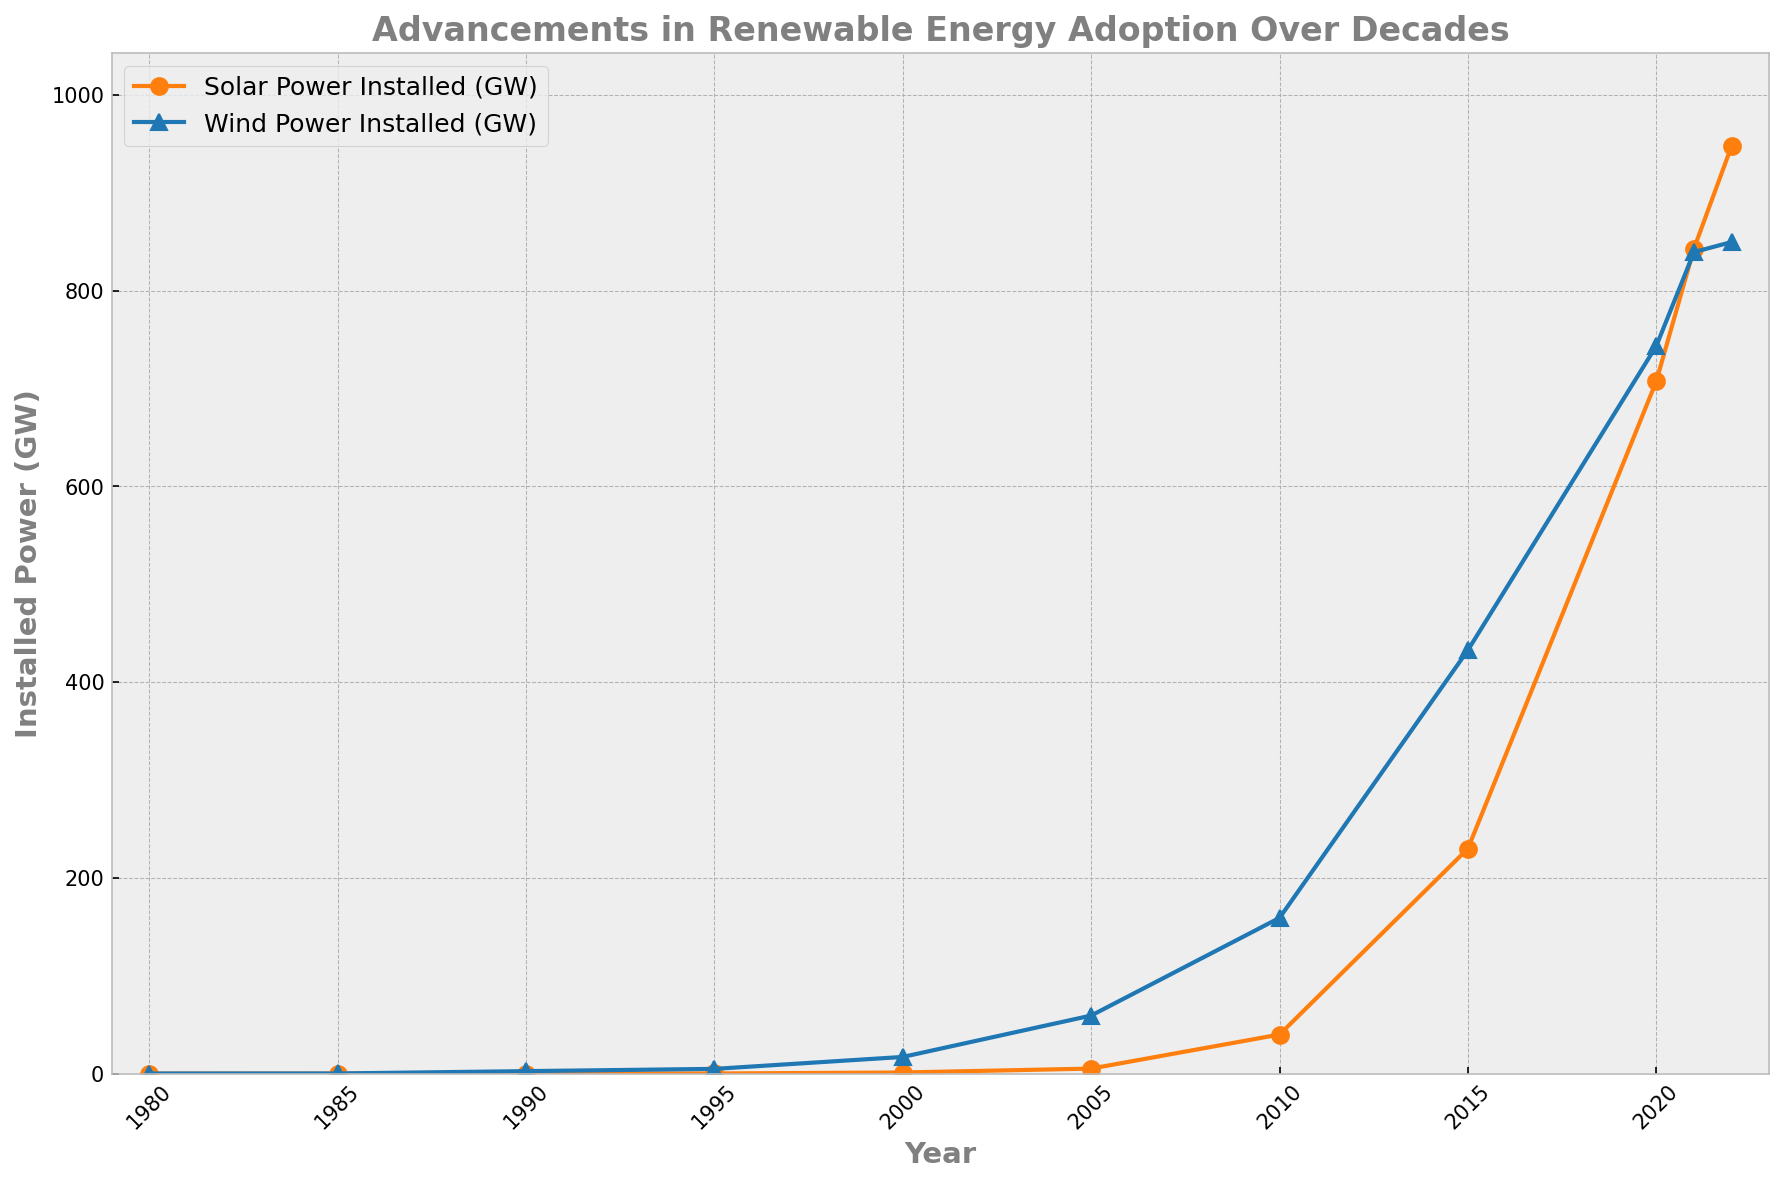What year saw the highest installation of solar power? By examining the figure, we look for the year where the solar power line (orange) reaches its peak. This occurs at the rightmost end of the graph.
Answer: 2022 Compare the installed wind power in 2000 and 2005. Which year had more, and by how much? Referring to the figure, we identify the wind power values for 2000 and 2005. Wind power in 2000 is 17 GW, and in 2005 it is 59.3 GW. Subtract the smaller value from the larger one: 59.3 - 17 = 42.3 GW.
Answer: 2005 by 42.3 GW From 2010 to 2015, which renewable energy source had the larger increase in installed power? Analyzing the figure, we find solar power went from 39.9 GW in 2010 to 229.9 GW in 2015 and wind power from 159.1 GW in 2010 to 432.7 GW in 2015. Solar increase: 229.9 - 39.9 = 190 GW. Wind increase: 432.7 - 159.1 = 273.6 GW. Compare the two increments.
Answer: Wind power What trend can we observe in solar power installation from 1980 to 2022? By viewing the trajectory of the orange line, we observe a gradual increase from 1980 to around 2000, followed by a rapid increase from about 2005 to 2022.
Answer: Gradual, then rapid increase Which year shows the greatest annual increase in wind power installation? By examining the blue line, we look for the steepest incline between two consecutive years. The largest jump occurs from 2005 (59.3 GW) to 2010 (159.1 GW). Increase: 159.1 - 59.3 = 99.8 GW.
Answer: 2005 to 2010 What is the combined installed power of solar and wind in 2020? From the figure, we see solar power is 707.5 GW and wind power is 743.5 GW in 2020. Summing these amounts: 707.5 + 743.5 = 1451 GW.
Answer: 1451 GW Which energy source had more installed power in 1990, and what is the difference? Referring to the plot, solar power was 0.031 GW and wind power was 2.5 GW in 1990. Difference: 2.5 - 0.031 = 2.469 GW. Wind has more.
Answer: Wind by 2.469 GW In which decade did solar power experience the most significant increase? Observing the orange line, the most prominent increase appears between 2010 and 2020, where solar power rose from 39.9 GW to 843.0 GW (not the exact boundary, but indicative of the decade trend).
Answer: 2010s How did the speed of adoption for wind power change from the 1980s to the 2000s? Studying the blue line, we see a noticeable increase beginning in the late 1990s and a significant upsurge from 2000 to 2010. Adoption accelerated starting in the 2000s.
Answer: Accelerated in the 2000s 